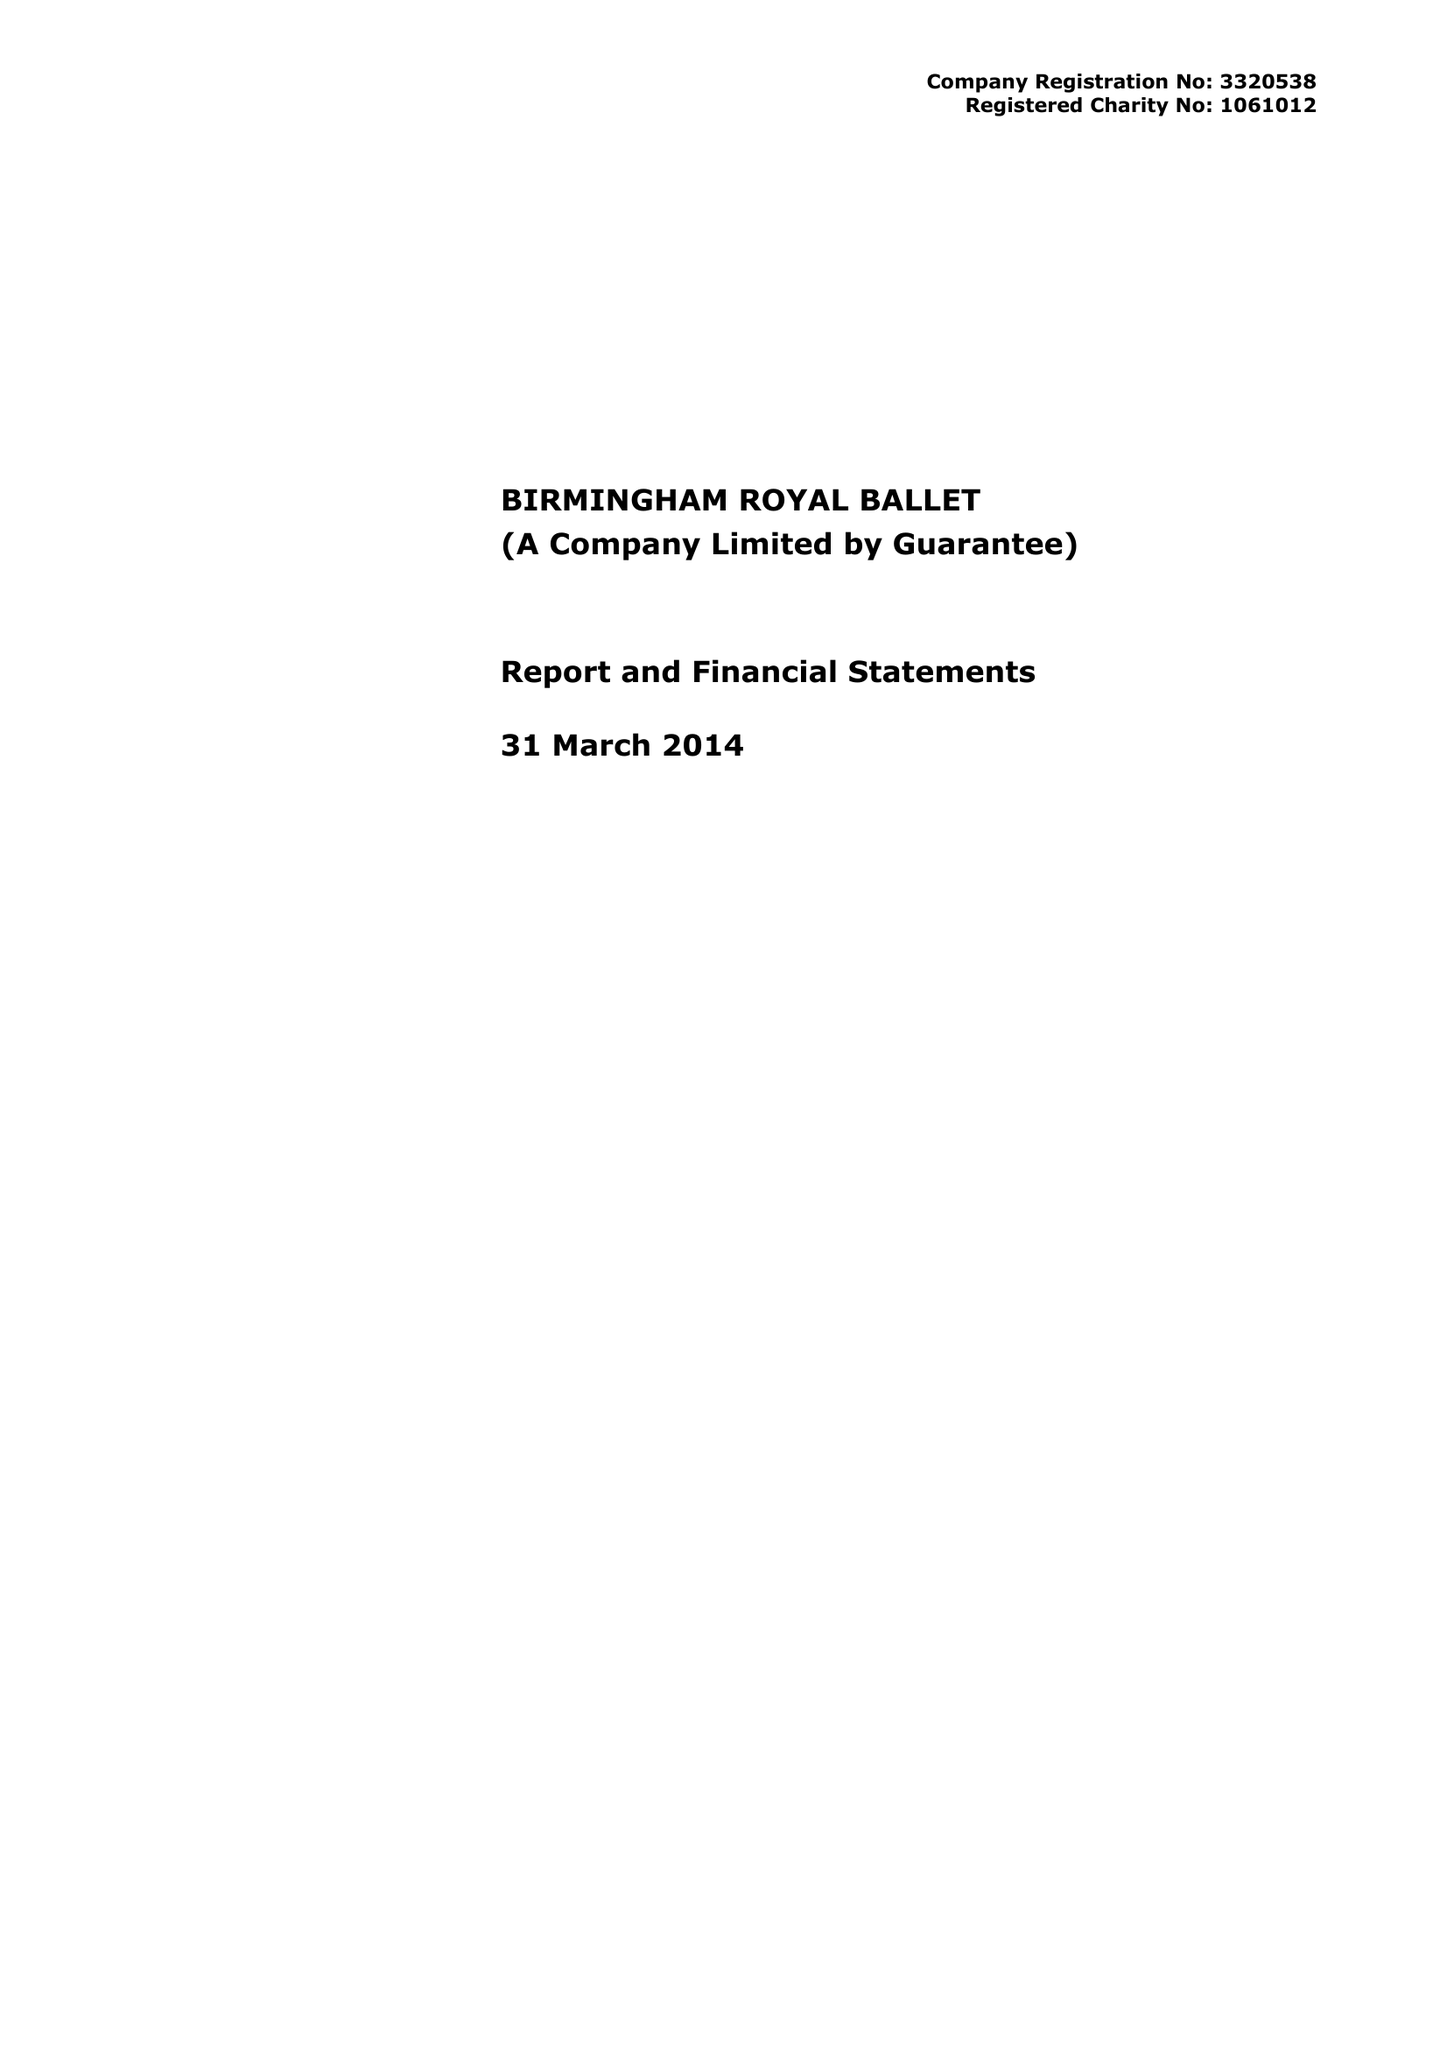What is the value for the report_date?
Answer the question using a single word or phrase. 2014-03-31 